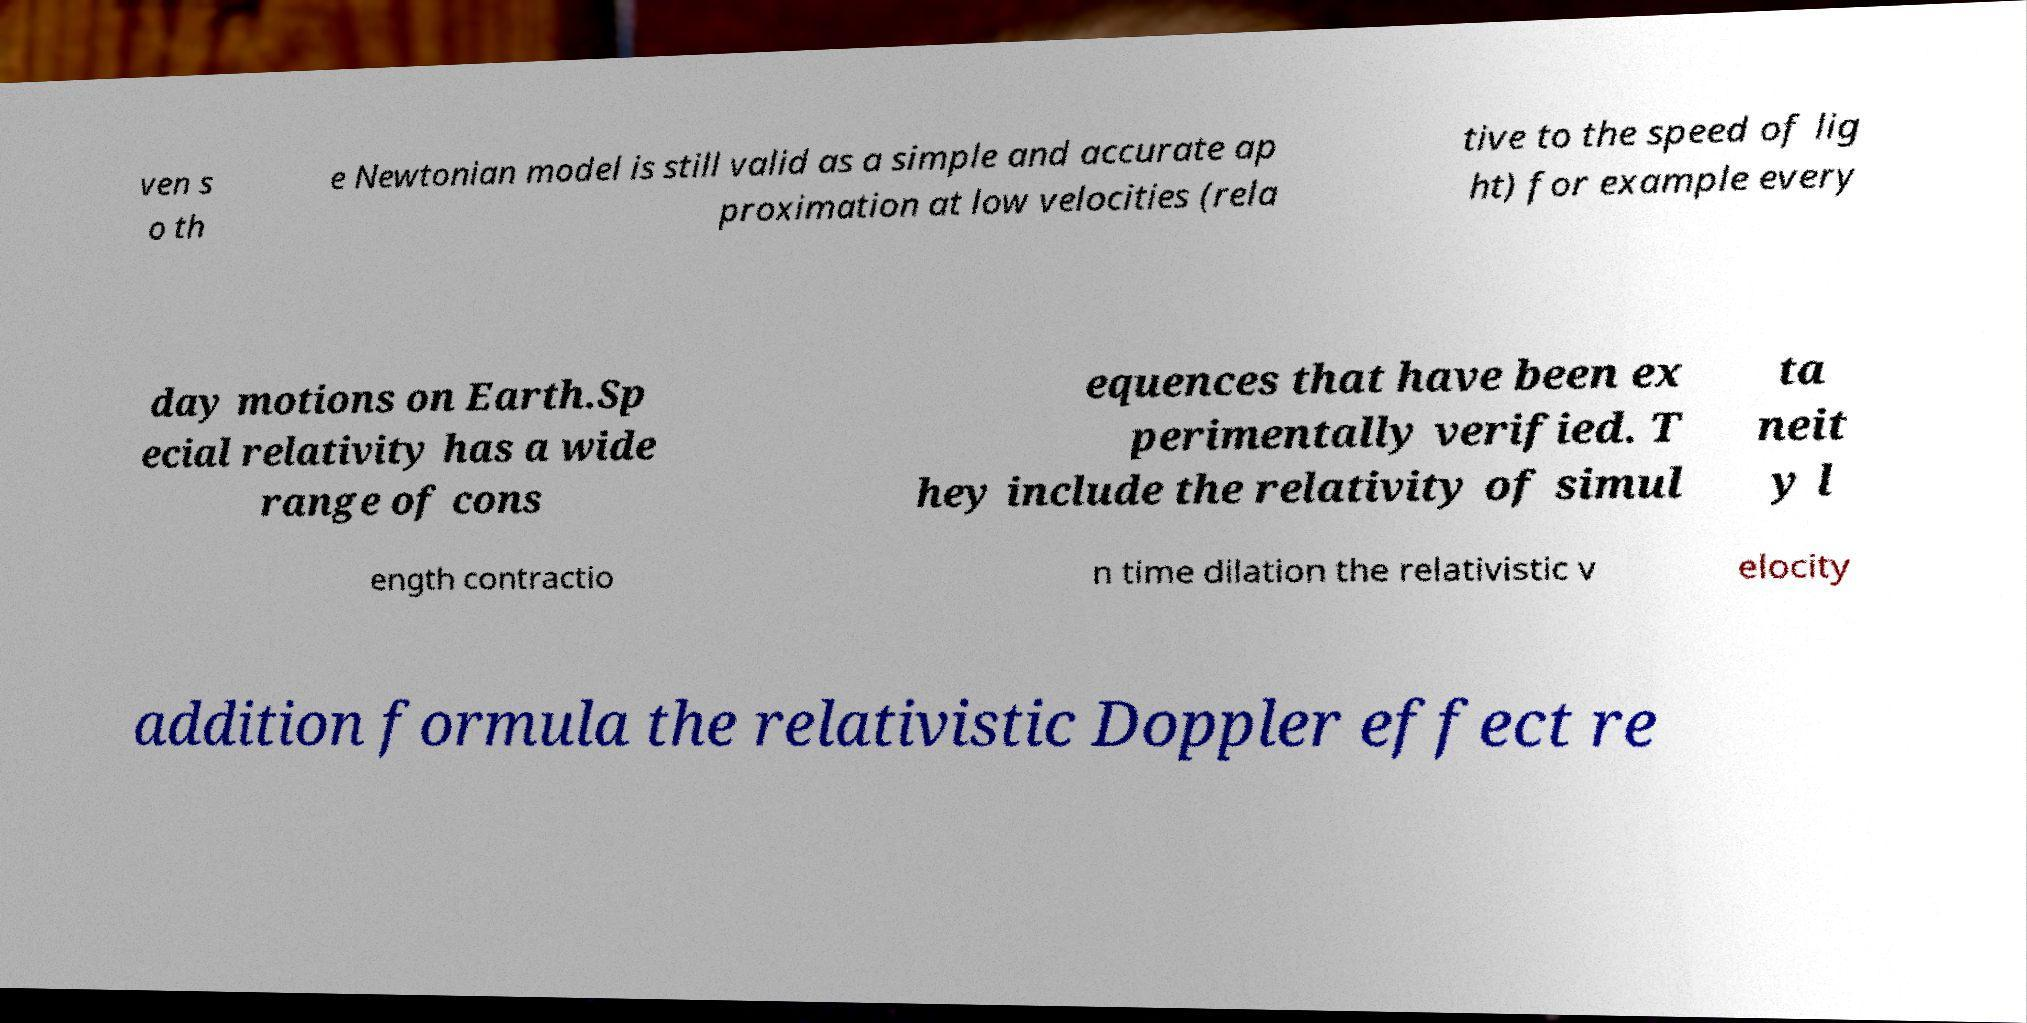Please identify and transcribe the text found in this image. ven s o th e Newtonian model is still valid as a simple and accurate ap proximation at low velocities (rela tive to the speed of lig ht) for example every day motions on Earth.Sp ecial relativity has a wide range of cons equences that have been ex perimentally verified. T hey include the relativity of simul ta neit y l ength contractio n time dilation the relativistic v elocity addition formula the relativistic Doppler effect re 